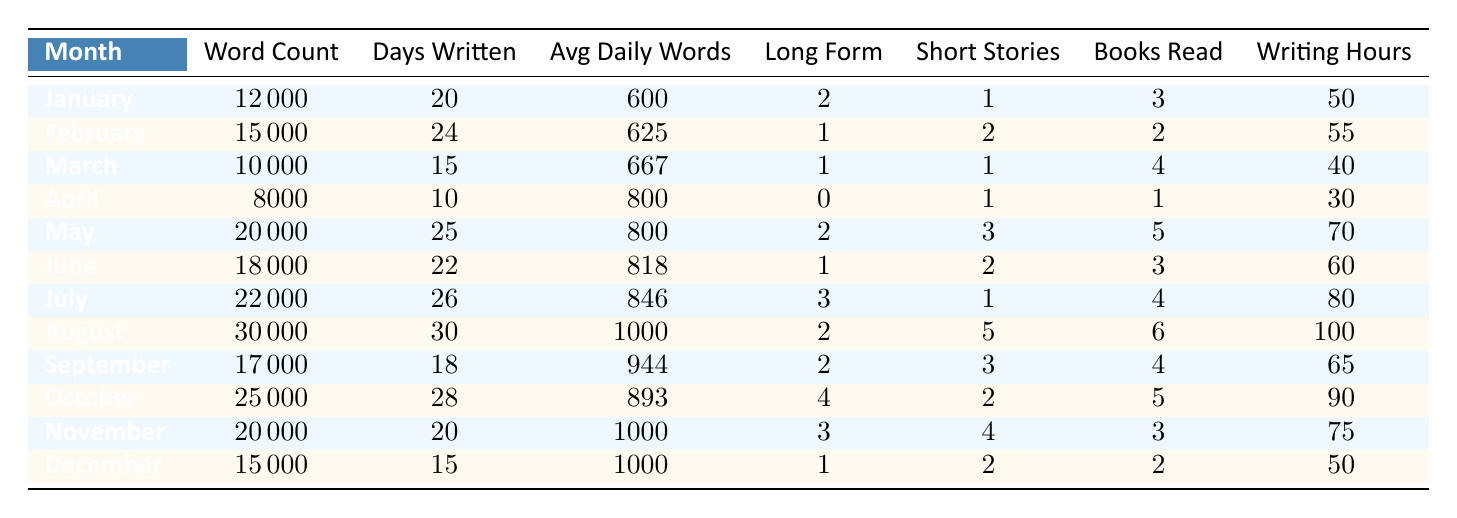What is the highest word count recorded in a month? By reviewing the table, we can see that August has the highest word count at 30,000.
Answer: 30,000 In which month did the writer write the fewest number of days? From the table, we can observe that April has the fewest days written, which is 10 days.
Answer: 10 How many long-form pieces were written in July? According to the table, the number of long-form pieces written in July is 3.
Answer: 3 What was the average daily word count in May? The table shows that the average daily word count in May is 800.
Answer: 800 In which month were the most inspirational books read? Looking at the table, we see that May had the most inspirational books read, totaling 5.
Answer: 5 What is the total writing hours over the first half of the year (January to June)? To find this, we add the writing hours for each month from January to June: 50 + 55 + 40 + 30 + 70 + 60 = 305 hours.
Answer: 305 What was the month with the highest average daily words? Upon checking the table, August has the highest average daily words with 1000.
Answer: 1000 How many short stories were written in November and December combined? In November, 4 short stories were written, and in December, 2 were written. Combining them gives us 4 + 2 = 6 short stories.
Answer: 6 Did the writer read more than 4 inspirational books in any month? By reviewing the data, we see that in May the writer read 5 inspirational books and in March, 4 were read; hence, the answer is yes.
Answer: Yes Which two months had the highest writing hours? Checking the table reveals August (100 hours) and July (80 hours) had the highest writing hours.
Answer: August and July 